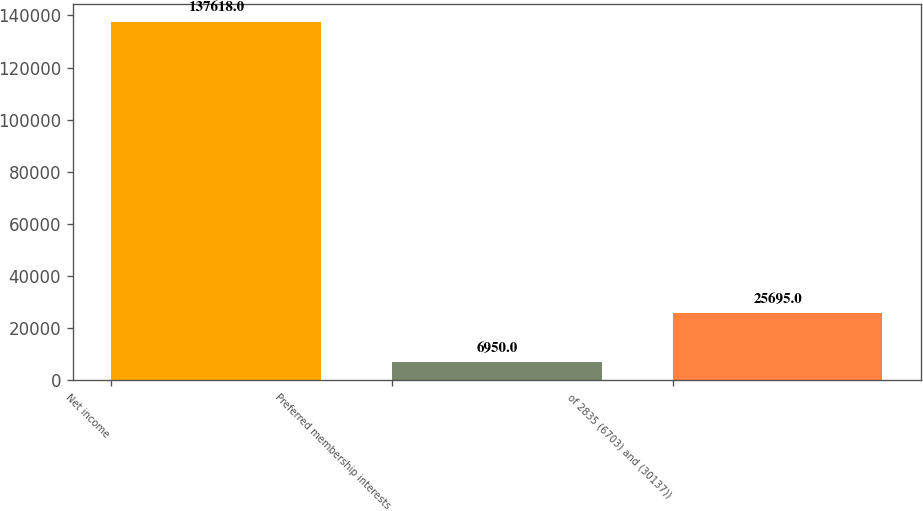Convert chart. <chart><loc_0><loc_0><loc_500><loc_500><bar_chart><fcel>Net income<fcel>Preferred membership interests<fcel>of 2835 (6703) and (30137))<nl><fcel>137618<fcel>6950<fcel>25695<nl></chart> 